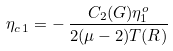Convert formula to latex. <formula><loc_0><loc_0><loc_500><loc_500>\eta _ { c \, 1 } = - \, \frac { C _ { 2 } ( G ) \eta _ { 1 } ^ { o } } { 2 ( \mu - 2 ) T ( R ) }</formula> 